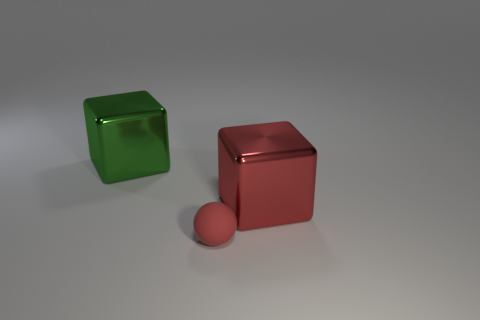What can you tell me about the lighting and shadows in the scene? The lighting in the scene is coming from the upper right corner, which is resulting in shadows casting to the left side of the objects. This suggests a single, relatively soft light source, given the soft edges of the shadows. The green cube casts a clearer, defined shadow compared to the red cube and sphere, possibly due to its translucent nature. 